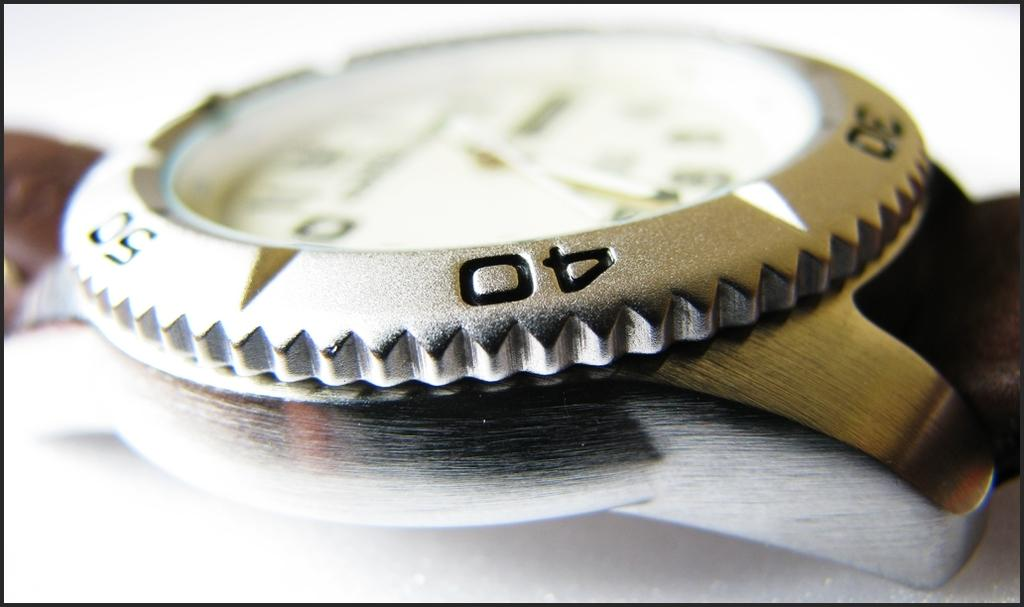<image>
Give a short and clear explanation of the subsequent image. The ring around a watch face as a 30, 40, and 50 on it. 